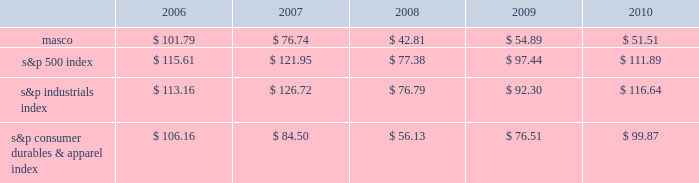Performance graph the table below compares the cumulative total shareholder return on our common stock with the cumulative total return of ( i ) the standard & poor 2019s 500 composite stock index ( 201cs&p 500 index 201d ) , ( ii ) the standard & poor 2019s industrials index ( 201cs&p industrials index 201d ) and ( iii ) the standard & poor 2019s consumer durables & apparel index ( 201cs&p consumer durables & apparel index 201d ) , from december 31 , 2005 through december 31 , 2010 , when the closing price of our common stock was $ 12.66 .
The graph assumes investments of $ 100 on december 31 , 2005 in our common stock and in each of the three indices and the reinvestment of dividends .
Performance graph 201020092008200720062005 s&p 500 index s&p industrials index s&p consumer durables & apparel index the table below sets forth the value , as of december 31 for each of the years indicated , of a $ 100 investment made on december 31 , 2005 in each of our common stock , the s&p 500 index , the s&p industrials index and the s&p consumer durables & apparel index and includes the reinvestment of dividends. .
In july 2007 , our board of directors authorized the purchase of up to 50 million shares of our common stock in open-market transactions or otherwise .
At december 31 , 2010 , we had remaining authorization to repurchase up to 27 million shares .
During 2010 , we repurchased and retired three million shares of our common stock , for cash aggregating $ 45 million to offset the dilutive impact of the 2010 grant of three million shares of long-term stock awards .
We did not purchase any shares during the three months ended december 31 , 2010. .
What was percent of the remaining authorization to repurchase of the 2007 authorized the purchase at december 2010? 
Rationale: the remaining authorization to repurchase of the 2007 authorized the purchase at december 2013
Computations: (27 / 50)
Answer: 0.54. 